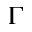Convert formula to latex. <formula><loc_0><loc_0><loc_500><loc_500>\Gamma</formula> 